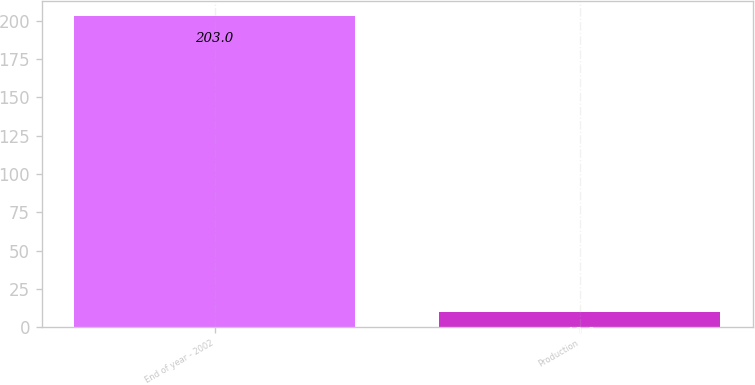Convert chart. <chart><loc_0><loc_0><loc_500><loc_500><bar_chart><fcel>End of year - 2002<fcel>Production<nl><fcel>203<fcel>10<nl></chart> 